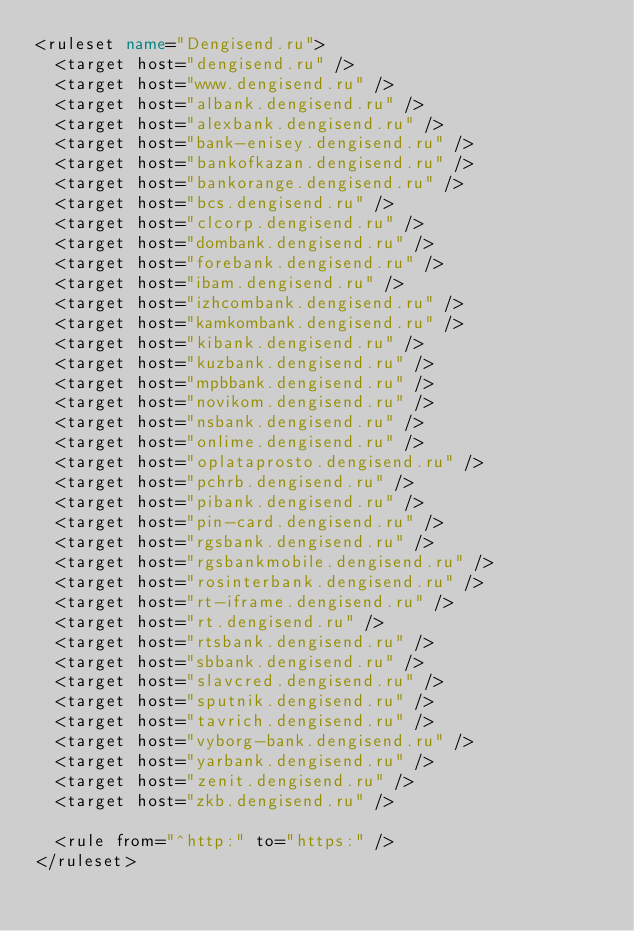<code> <loc_0><loc_0><loc_500><loc_500><_XML_><ruleset name="Dengisend.ru">
	<target host="dengisend.ru" />
	<target host="www.dengisend.ru" />
	<target host="albank.dengisend.ru" />
	<target host="alexbank.dengisend.ru" />
	<target host="bank-enisey.dengisend.ru" />
	<target host="bankofkazan.dengisend.ru" />
	<target host="bankorange.dengisend.ru" />
	<target host="bcs.dengisend.ru" />
	<target host="clcorp.dengisend.ru" />
	<target host="dombank.dengisend.ru" />
	<target host="forebank.dengisend.ru" />
	<target host="ibam.dengisend.ru" />
	<target host="izhcombank.dengisend.ru" />
	<target host="kamkombank.dengisend.ru" />
	<target host="kibank.dengisend.ru" />
	<target host="kuzbank.dengisend.ru" />
	<target host="mpbbank.dengisend.ru" />
	<target host="novikom.dengisend.ru" />
	<target host="nsbank.dengisend.ru" />
	<target host="onlime.dengisend.ru" />
	<target host="oplataprosto.dengisend.ru" />
	<target host="pchrb.dengisend.ru" />
	<target host="pibank.dengisend.ru" />
	<target host="pin-card.dengisend.ru" />
	<target host="rgsbank.dengisend.ru" />
	<target host="rgsbankmobile.dengisend.ru" />
	<target host="rosinterbank.dengisend.ru" />
	<target host="rt-iframe.dengisend.ru" />
	<target host="rt.dengisend.ru" />
	<target host="rtsbank.dengisend.ru" />
	<target host="sbbank.dengisend.ru" />
	<target host="slavcred.dengisend.ru" />
	<target host="sputnik.dengisend.ru" />
	<target host="tavrich.dengisend.ru" />
	<target host="vyborg-bank.dengisend.ru" />
	<target host="yarbank.dengisend.ru" />
	<target host="zenit.dengisend.ru" />
	<target host="zkb.dengisend.ru" />

	<rule from="^http:" to="https:" />
</ruleset>
</code> 